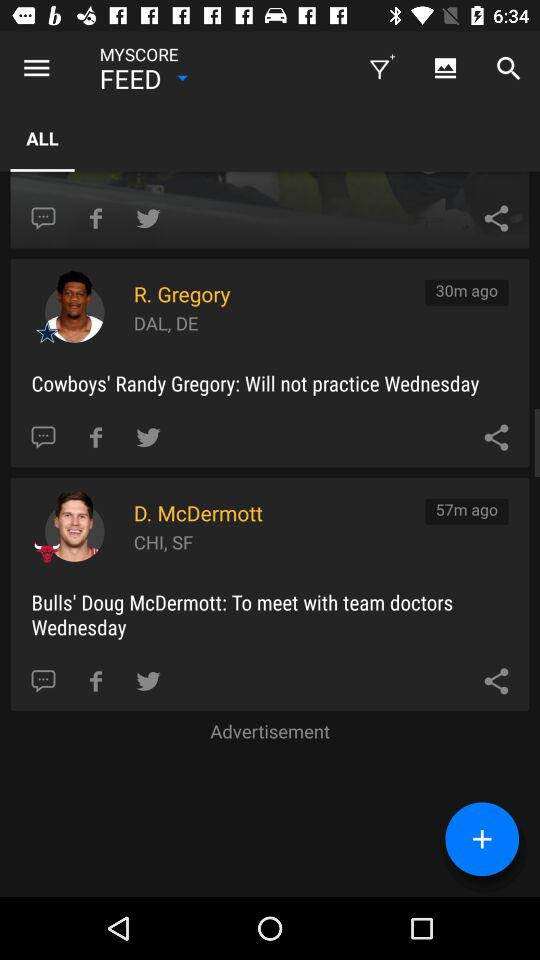How many more minutes ago was the update for D. McDermott than R. Gregory? 27 